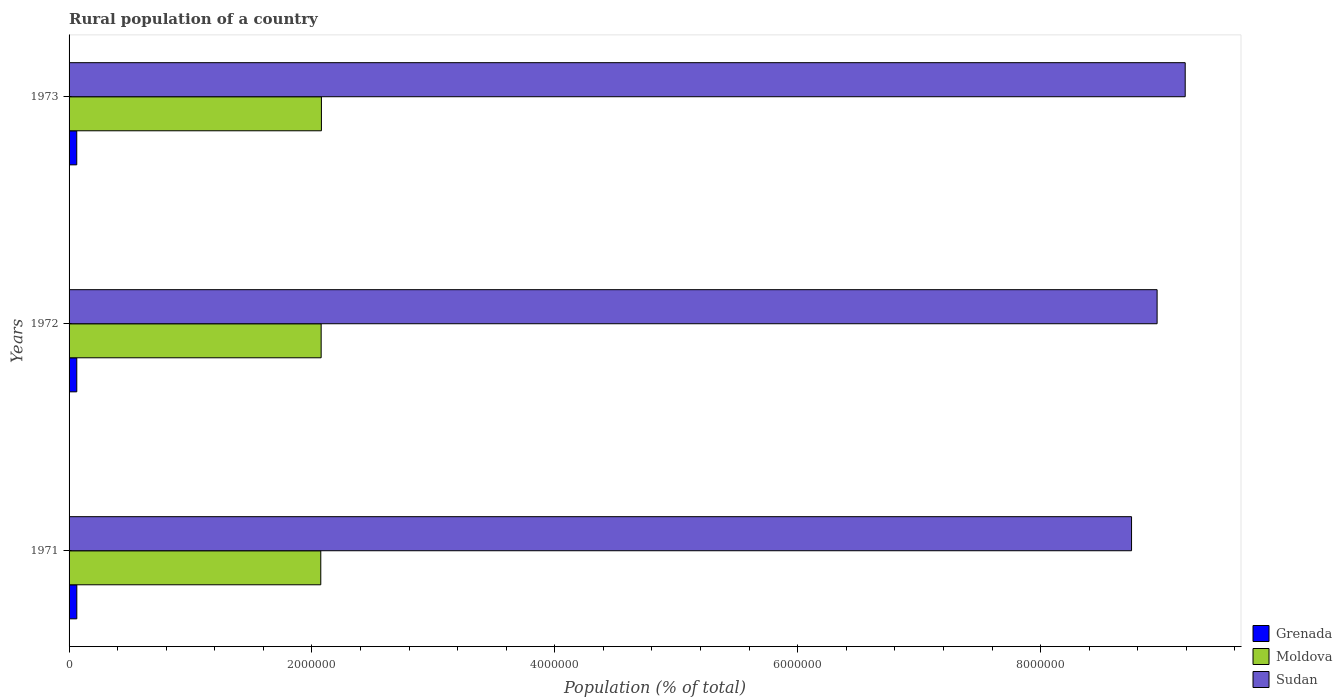How many different coloured bars are there?
Keep it short and to the point. 3. Are the number of bars per tick equal to the number of legend labels?
Provide a succinct answer. Yes. Are the number of bars on each tick of the Y-axis equal?
Keep it short and to the point. Yes. How many bars are there on the 2nd tick from the bottom?
Offer a terse response. 3. In how many cases, is the number of bars for a given year not equal to the number of legend labels?
Ensure brevity in your answer.  0. What is the rural population in Grenada in 1971?
Keep it short and to the point. 6.38e+04. Across all years, what is the maximum rural population in Sudan?
Your answer should be very brief. 9.19e+06. Across all years, what is the minimum rural population in Moldova?
Make the answer very short. 2.07e+06. In which year was the rural population in Sudan maximum?
Provide a short and direct response. 1973. In which year was the rural population in Sudan minimum?
Offer a very short reply. 1971. What is the total rural population in Moldova in the graph?
Offer a terse response. 6.23e+06. What is the difference between the rural population in Grenada in 1971 and that in 1972?
Keep it short and to the point. 231. What is the difference between the rural population in Grenada in 1971 and the rural population in Moldova in 1972?
Keep it short and to the point. -2.01e+06. What is the average rural population in Grenada per year?
Keep it short and to the point. 6.35e+04. In the year 1971, what is the difference between the rural population in Sudan and rural population in Moldova?
Keep it short and to the point. 6.68e+06. In how many years, is the rural population in Sudan greater than 4000000 %?
Offer a terse response. 3. What is the ratio of the rural population in Grenada in 1971 to that in 1973?
Your response must be concise. 1.01. Is the rural population in Sudan in 1971 less than that in 1973?
Keep it short and to the point. Yes. Is the difference between the rural population in Sudan in 1971 and 1972 greater than the difference between the rural population in Moldova in 1971 and 1972?
Ensure brevity in your answer.  No. What is the difference between the highest and the second highest rural population in Grenada?
Give a very brief answer. 231. What is the difference between the highest and the lowest rural population in Moldova?
Give a very brief answer. 5290. In how many years, is the rural population in Moldova greater than the average rural population in Moldova taken over all years?
Offer a very short reply. 2. Is the sum of the rural population in Sudan in 1971 and 1973 greater than the maximum rural population in Grenada across all years?
Provide a succinct answer. Yes. What does the 2nd bar from the top in 1972 represents?
Your answer should be very brief. Moldova. What does the 2nd bar from the bottom in 1972 represents?
Your answer should be very brief. Moldova. Is it the case that in every year, the sum of the rural population in Sudan and rural population in Grenada is greater than the rural population in Moldova?
Make the answer very short. Yes. Are all the bars in the graph horizontal?
Provide a succinct answer. Yes. How many years are there in the graph?
Offer a very short reply. 3. Are the values on the major ticks of X-axis written in scientific E-notation?
Make the answer very short. No. How many legend labels are there?
Offer a terse response. 3. What is the title of the graph?
Offer a very short reply. Rural population of a country. Does "Ethiopia" appear as one of the legend labels in the graph?
Provide a short and direct response. No. What is the label or title of the X-axis?
Keep it short and to the point. Population (% of total). What is the label or title of the Y-axis?
Your answer should be compact. Years. What is the Population (% of total) of Grenada in 1971?
Offer a terse response. 6.38e+04. What is the Population (% of total) in Moldova in 1971?
Offer a very short reply. 2.07e+06. What is the Population (% of total) of Sudan in 1971?
Your answer should be compact. 8.75e+06. What is the Population (% of total) in Grenada in 1972?
Ensure brevity in your answer.  6.35e+04. What is the Population (% of total) of Moldova in 1972?
Make the answer very short. 2.08e+06. What is the Population (% of total) in Sudan in 1972?
Provide a succinct answer. 8.96e+06. What is the Population (% of total) in Grenada in 1973?
Keep it short and to the point. 6.33e+04. What is the Population (% of total) in Moldova in 1973?
Make the answer very short. 2.08e+06. What is the Population (% of total) of Sudan in 1973?
Your response must be concise. 9.19e+06. Across all years, what is the maximum Population (% of total) in Grenada?
Your response must be concise. 6.38e+04. Across all years, what is the maximum Population (% of total) of Moldova?
Provide a succinct answer. 2.08e+06. Across all years, what is the maximum Population (% of total) in Sudan?
Offer a very short reply. 9.19e+06. Across all years, what is the minimum Population (% of total) in Grenada?
Provide a short and direct response. 6.33e+04. Across all years, what is the minimum Population (% of total) in Moldova?
Offer a terse response. 2.07e+06. Across all years, what is the minimum Population (% of total) in Sudan?
Provide a succinct answer. 8.75e+06. What is the total Population (% of total) in Grenada in the graph?
Offer a very short reply. 1.91e+05. What is the total Population (% of total) of Moldova in the graph?
Make the answer very short. 6.23e+06. What is the total Population (% of total) of Sudan in the graph?
Offer a very short reply. 2.69e+07. What is the difference between the Population (% of total) in Grenada in 1971 and that in 1972?
Offer a very short reply. 231. What is the difference between the Population (% of total) in Moldova in 1971 and that in 1972?
Provide a short and direct response. -3126. What is the difference between the Population (% of total) in Sudan in 1971 and that in 1972?
Ensure brevity in your answer.  -2.10e+05. What is the difference between the Population (% of total) of Grenada in 1971 and that in 1973?
Offer a terse response. 506. What is the difference between the Population (% of total) in Moldova in 1971 and that in 1973?
Offer a terse response. -5290. What is the difference between the Population (% of total) of Sudan in 1971 and that in 1973?
Your answer should be very brief. -4.42e+05. What is the difference between the Population (% of total) of Grenada in 1972 and that in 1973?
Your response must be concise. 275. What is the difference between the Population (% of total) of Moldova in 1972 and that in 1973?
Offer a terse response. -2164. What is the difference between the Population (% of total) of Sudan in 1972 and that in 1973?
Offer a very short reply. -2.31e+05. What is the difference between the Population (% of total) of Grenada in 1971 and the Population (% of total) of Moldova in 1972?
Provide a succinct answer. -2.01e+06. What is the difference between the Population (% of total) in Grenada in 1971 and the Population (% of total) in Sudan in 1972?
Offer a terse response. -8.90e+06. What is the difference between the Population (% of total) of Moldova in 1971 and the Population (% of total) of Sudan in 1972?
Keep it short and to the point. -6.89e+06. What is the difference between the Population (% of total) of Grenada in 1971 and the Population (% of total) of Moldova in 1973?
Make the answer very short. -2.01e+06. What is the difference between the Population (% of total) of Grenada in 1971 and the Population (% of total) of Sudan in 1973?
Offer a terse response. -9.13e+06. What is the difference between the Population (% of total) of Moldova in 1971 and the Population (% of total) of Sudan in 1973?
Keep it short and to the point. -7.12e+06. What is the difference between the Population (% of total) in Grenada in 1972 and the Population (% of total) in Moldova in 1973?
Your response must be concise. -2.01e+06. What is the difference between the Population (% of total) in Grenada in 1972 and the Population (% of total) in Sudan in 1973?
Ensure brevity in your answer.  -9.13e+06. What is the difference between the Population (% of total) of Moldova in 1972 and the Population (% of total) of Sudan in 1973?
Offer a terse response. -7.11e+06. What is the average Population (% of total) in Grenada per year?
Make the answer very short. 6.35e+04. What is the average Population (% of total) of Moldova per year?
Offer a terse response. 2.08e+06. What is the average Population (% of total) in Sudan per year?
Provide a succinct answer. 8.97e+06. In the year 1971, what is the difference between the Population (% of total) of Grenada and Population (% of total) of Moldova?
Provide a short and direct response. -2.01e+06. In the year 1971, what is the difference between the Population (% of total) in Grenada and Population (% of total) in Sudan?
Ensure brevity in your answer.  -8.69e+06. In the year 1971, what is the difference between the Population (% of total) of Moldova and Population (% of total) of Sudan?
Your response must be concise. -6.68e+06. In the year 1972, what is the difference between the Population (% of total) in Grenada and Population (% of total) in Moldova?
Make the answer very short. -2.01e+06. In the year 1972, what is the difference between the Population (% of total) of Grenada and Population (% of total) of Sudan?
Offer a very short reply. -8.90e+06. In the year 1972, what is the difference between the Population (% of total) in Moldova and Population (% of total) in Sudan?
Make the answer very short. -6.88e+06. In the year 1973, what is the difference between the Population (% of total) of Grenada and Population (% of total) of Moldova?
Offer a very short reply. -2.01e+06. In the year 1973, what is the difference between the Population (% of total) of Grenada and Population (% of total) of Sudan?
Your response must be concise. -9.13e+06. In the year 1973, what is the difference between the Population (% of total) in Moldova and Population (% of total) in Sudan?
Provide a succinct answer. -7.11e+06. What is the ratio of the Population (% of total) of Grenada in 1971 to that in 1972?
Provide a succinct answer. 1. What is the ratio of the Population (% of total) in Moldova in 1971 to that in 1972?
Your answer should be compact. 1. What is the ratio of the Population (% of total) of Sudan in 1971 to that in 1972?
Provide a short and direct response. 0.98. What is the ratio of the Population (% of total) of Grenada in 1971 to that in 1973?
Your response must be concise. 1.01. What is the ratio of the Population (% of total) in Moldova in 1971 to that in 1973?
Ensure brevity in your answer.  1. What is the ratio of the Population (% of total) in Sudan in 1971 to that in 1973?
Your answer should be compact. 0.95. What is the ratio of the Population (% of total) in Sudan in 1972 to that in 1973?
Provide a short and direct response. 0.97. What is the difference between the highest and the second highest Population (% of total) in Grenada?
Offer a terse response. 231. What is the difference between the highest and the second highest Population (% of total) of Moldova?
Provide a succinct answer. 2164. What is the difference between the highest and the second highest Population (% of total) of Sudan?
Keep it short and to the point. 2.31e+05. What is the difference between the highest and the lowest Population (% of total) of Grenada?
Your answer should be compact. 506. What is the difference between the highest and the lowest Population (% of total) of Moldova?
Keep it short and to the point. 5290. What is the difference between the highest and the lowest Population (% of total) of Sudan?
Give a very brief answer. 4.42e+05. 